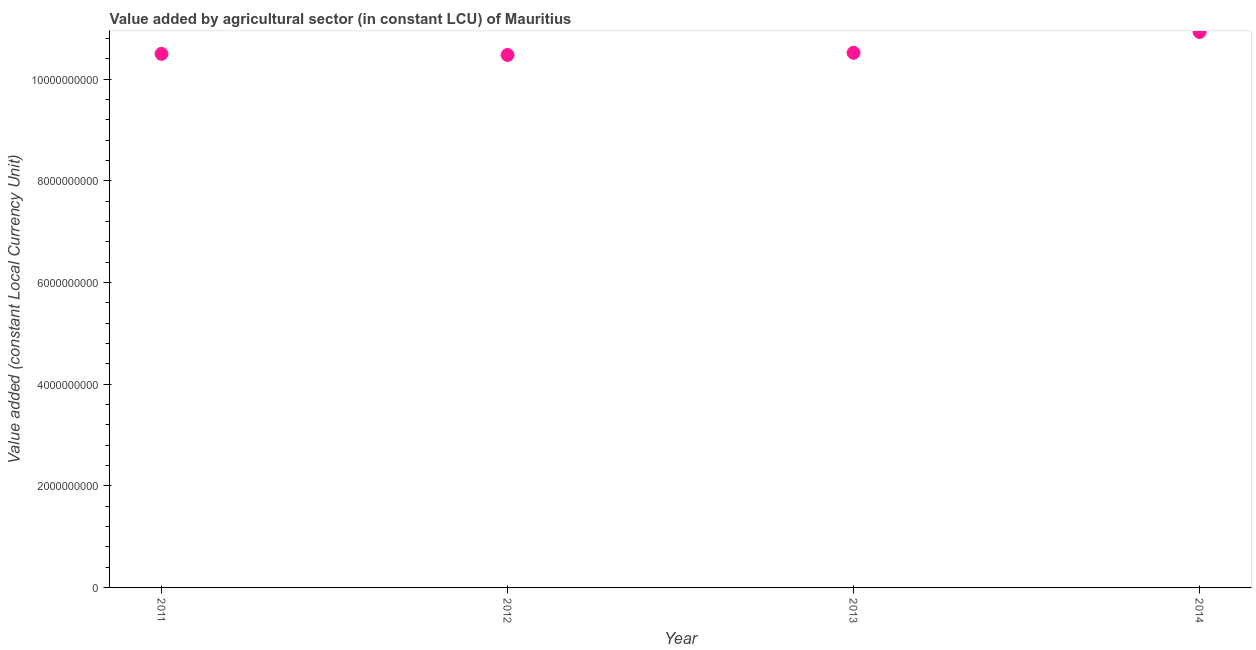What is the value added by agriculture sector in 2012?
Your response must be concise. 1.05e+1. Across all years, what is the maximum value added by agriculture sector?
Give a very brief answer. 1.09e+1. Across all years, what is the minimum value added by agriculture sector?
Provide a succinct answer. 1.05e+1. In which year was the value added by agriculture sector maximum?
Provide a succinct answer. 2014. In which year was the value added by agriculture sector minimum?
Offer a very short reply. 2012. What is the sum of the value added by agriculture sector?
Offer a terse response. 4.24e+1. What is the difference between the value added by agriculture sector in 2011 and 2014?
Your response must be concise. -4.31e+08. What is the average value added by agriculture sector per year?
Ensure brevity in your answer.  1.06e+1. What is the median value added by agriculture sector?
Provide a short and direct response. 1.05e+1. In how many years, is the value added by agriculture sector greater than 8400000000 LCU?
Your response must be concise. 4. What is the ratio of the value added by agriculture sector in 2013 to that in 2014?
Offer a very short reply. 0.96. Is the difference between the value added by agriculture sector in 2013 and 2014 greater than the difference between any two years?
Your answer should be very brief. No. What is the difference between the highest and the second highest value added by agriculture sector?
Provide a succinct answer. 4.10e+08. Is the sum of the value added by agriculture sector in 2013 and 2014 greater than the maximum value added by agriculture sector across all years?
Make the answer very short. Yes. What is the difference between the highest and the lowest value added by agriculture sector?
Your answer should be very brief. 4.52e+08. In how many years, is the value added by agriculture sector greater than the average value added by agriculture sector taken over all years?
Your answer should be compact. 1. Does the value added by agriculture sector monotonically increase over the years?
Provide a short and direct response. No. What is the difference between two consecutive major ticks on the Y-axis?
Your answer should be compact. 2.00e+09. Are the values on the major ticks of Y-axis written in scientific E-notation?
Your response must be concise. No. What is the title of the graph?
Offer a very short reply. Value added by agricultural sector (in constant LCU) of Mauritius. What is the label or title of the Y-axis?
Give a very brief answer. Value added (constant Local Currency Unit). What is the Value added (constant Local Currency Unit) in 2011?
Provide a succinct answer. 1.05e+1. What is the Value added (constant Local Currency Unit) in 2012?
Ensure brevity in your answer.  1.05e+1. What is the Value added (constant Local Currency Unit) in 2013?
Your response must be concise. 1.05e+1. What is the Value added (constant Local Currency Unit) in 2014?
Ensure brevity in your answer.  1.09e+1. What is the difference between the Value added (constant Local Currency Unit) in 2011 and 2012?
Ensure brevity in your answer.  2.10e+07. What is the difference between the Value added (constant Local Currency Unit) in 2011 and 2013?
Ensure brevity in your answer.  -2.09e+07. What is the difference between the Value added (constant Local Currency Unit) in 2011 and 2014?
Make the answer very short. -4.31e+08. What is the difference between the Value added (constant Local Currency Unit) in 2012 and 2013?
Make the answer very short. -4.19e+07. What is the difference between the Value added (constant Local Currency Unit) in 2012 and 2014?
Provide a short and direct response. -4.52e+08. What is the difference between the Value added (constant Local Currency Unit) in 2013 and 2014?
Offer a very short reply. -4.10e+08. What is the ratio of the Value added (constant Local Currency Unit) in 2011 to that in 2012?
Keep it short and to the point. 1. What is the ratio of the Value added (constant Local Currency Unit) in 2011 to that in 2013?
Give a very brief answer. 1. 